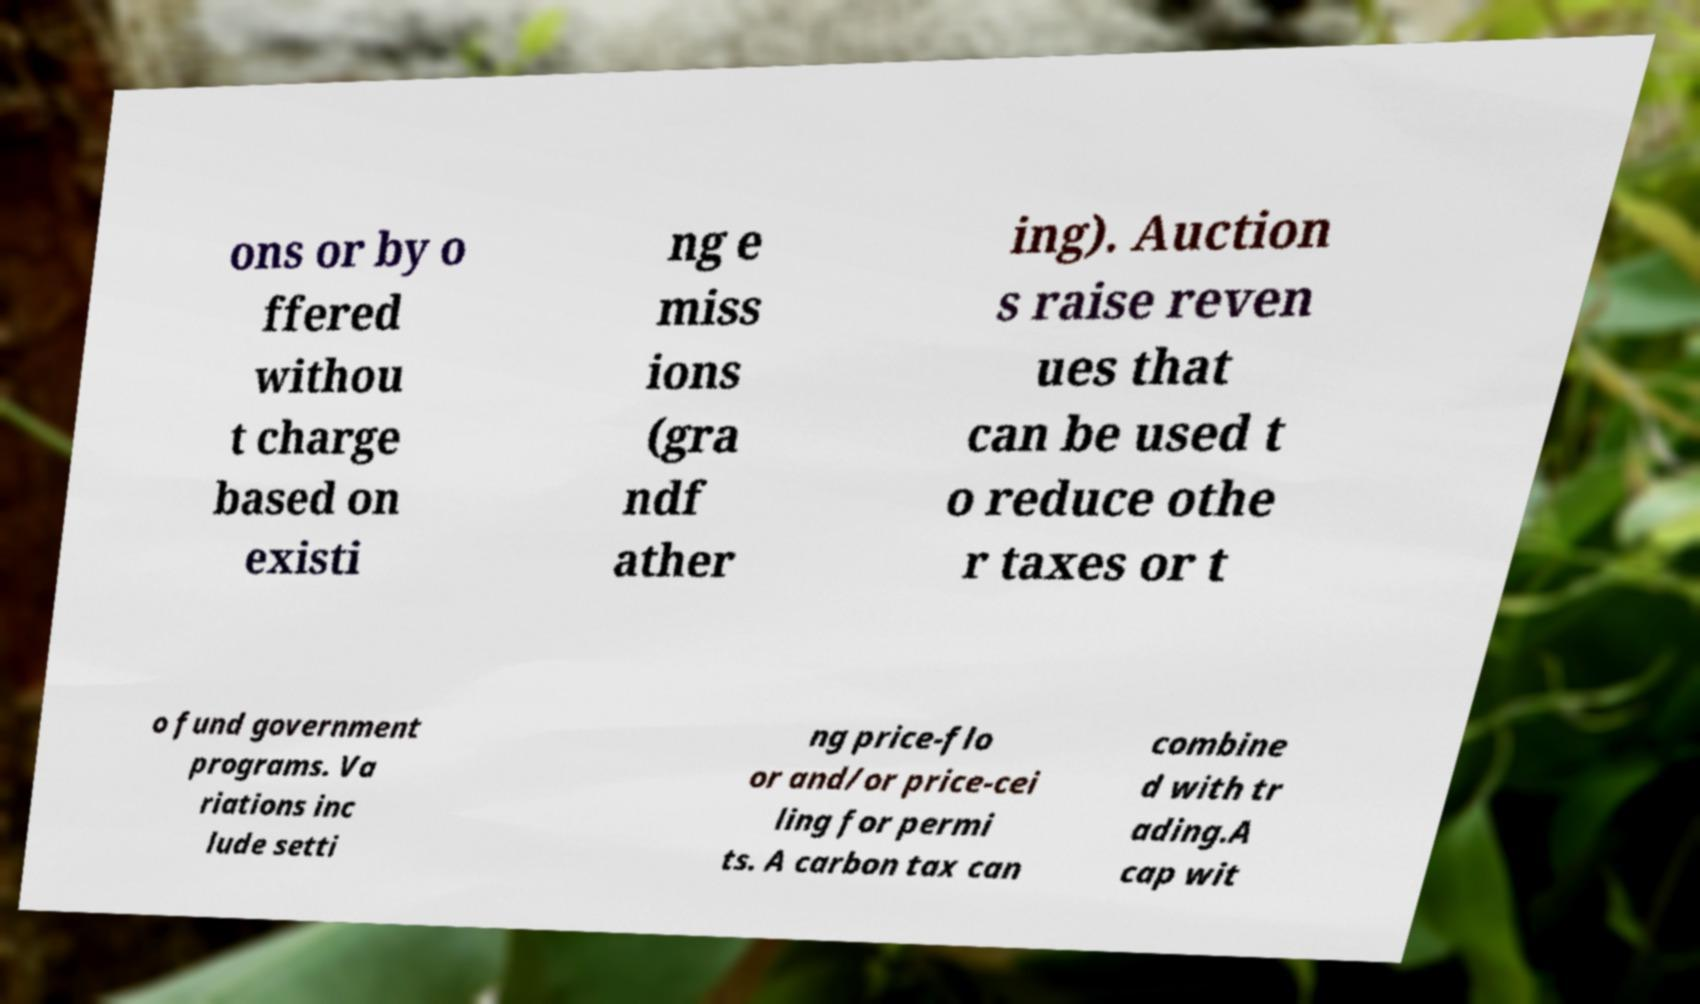Could you assist in decoding the text presented in this image and type it out clearly? ons or by o ffered withou t charge based on existi ng e miss ions (gra ndf ather ing). Auction s raise reven ues that can be used t o reduce othe r taxes or t o fund government programs. Va riations inc lude setti ng price-flo or and/or price-cei ling for permi ts. A carbon tax can combine d with tr ading.A cap wit 